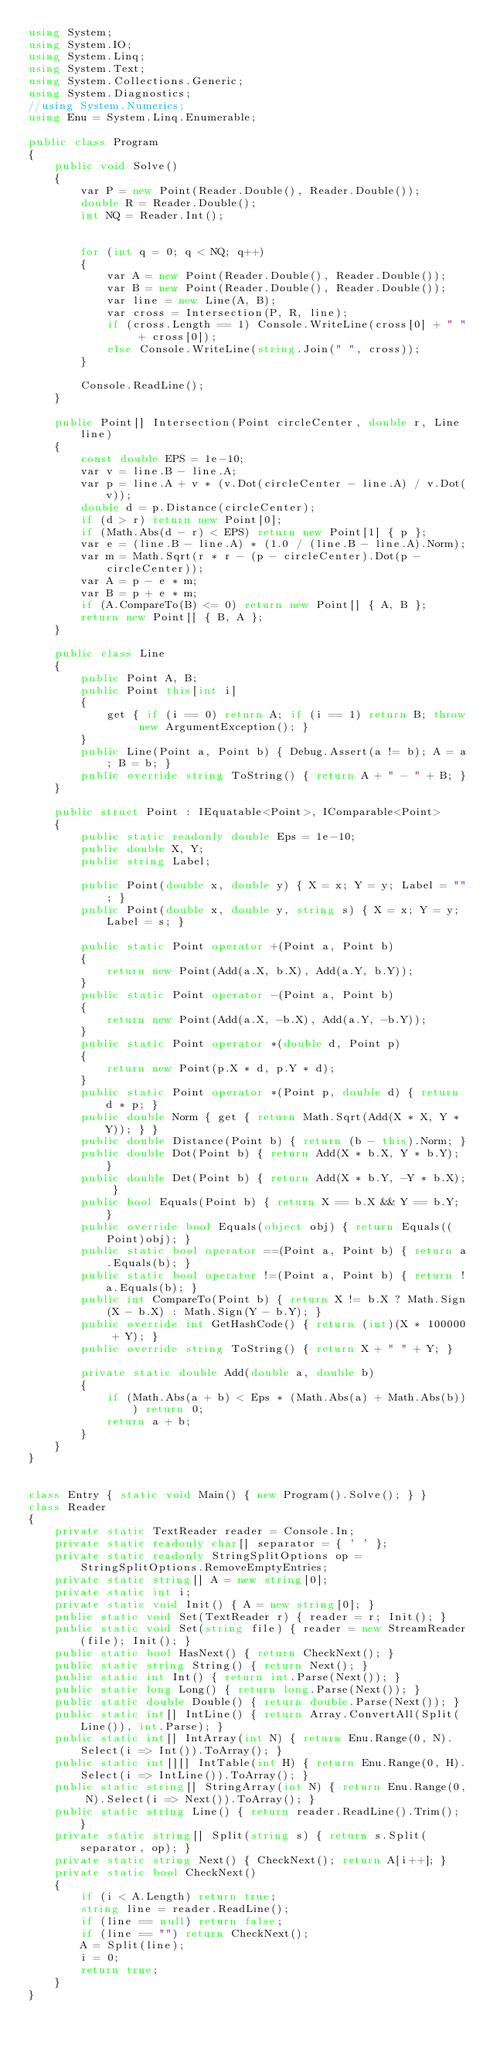Convert code to text. <code><loc_0><loc_0><loc_500><loc_500><_C#_>using System;
using System.IO;
using System.Linq;
using System.Text;
using System.Collections.Generic;
using System.Diagnostics;
//using System.Numerics;
using Enu = System.Linq.Enumerable;

public class Program
{
    public void Solve()
    {
        var P = new Point(Reader.Double(), Reader.Double());
        double R = Reader.Double();
        int NQ = Reader.Int();


        for (int q = 0; q < NQ; q++)
        {
            var A = new Point(Reader.Double(), Reader.Double());
            var B = new Point(Reader.Double(), Reader.Double());
            var line = new Line(A, B);
            var cross = Intersection(P, R, line);
            if (cross.Length == 1) Console.WriteLine(cross[0] + " " + cross[0]);
            else Console.WriteLine(string.Join(" ", cross));
        }

        Console.ReadLine();
    }

    public Point[] Intersection(Point circleCenter, double r, Line line)
    {
        const double EPS = 1e-10;
        var v = line.B - line.A;
        var p = line.A + v * (v.Dot(circleCenter - line.A) / v.Dot(v));
        double d = p.Distance(circleCenter);
        if (d > r) return new Point[0];
        if (Math.Abs(d - r) < EPS) return new Point[1] { p };
        var e = (line.B - line.A) * (1.0 / (line.B - line.A).Norm);
        var m = Math.Sqrt(r * r - (p - circleCenter).Dot(p - circleCenter));
        var A = p - e * m;
        var B = p + e * m;
        if (A.CompareTo(B) <= 0) return new Point[] { A, B };
        return new Point[] { B, A };
    }

    public class Line
    {
        public Point A, B;
        public Point this[int i]
        {
            get { if (i == 0) return A; if (i == 1) return B; throw new ArgumentException(); }
        }
        public Line(Point a, Point b) { Debug.Assert(a != b); A = a; B = b; }
        public override string ToString() { return A + " - " + B; }
    }

    public struct Point : IEquatable<Point>, IComparable<Point>
    {
        public static readonly double Eps = 1e-10;
        public double X, Y;
        public string Label;

        public Point(double x, double y) { X = x; Y = y; Label = ""; }
        public Point(double x, double y, string s) { X = x; Y = y; Label = s; }

        public static Point operator +(Point a, Point b)
        {
            return new Point(Add(a.X, b.X), Add(a.Y, b.Y));
        }
        public static Point operator -(Point a, Point b)
        {
            return new Point(Add(a.X, -b.X), Add(a.Y, -b.Y));
        }
        public static Point operator *(double d, Point p)
        {
            return new Point(p.X * d, p.Y * d);
        }
        public static Point operator *(Point p, double d) { return d * p; }
        public double Norm { get { return Math.Sqrt(Add(X * X, Y * Y)); } }
        public double Distance(Point b) { return (b - this).Norm; }
        public double Dot(Point b) { return Add(X * b.X, Y * b.Y); }
        public double Det(Point b) { return Add(X * b.Y, -Y * b.X); }
        public bool Equals(Point b) { return X == b.X && Y == b.Y; }
        public override bool Equals(object obj) { return Equals((Point)obj); }
        public static bool operator ==(Point a, Point b) { return a.Equals(b); }
        public static bool operator !=(Point a, Point b) { return !a.Equals(b); }
        public int CompareTo(Point b) { return X != b.X ? Math.Sign(X - b.X) : Math.Sign(Y - b.Y); }
        public override int GetHashCode() { return (int)(X * 100000 + Y); }
        public override string ToString() { return X + " " + Y; }

        private static double Add(double a, double b)
        {
            if (Math.Abs(a + b) < Eps * (Math.Abs(a) + Math.Abs(b))) return 0;
            return a + b;
        }
    }
}


class Entry { static void Main() { new Program().Solve(); } }
class Reader
{
    private static TextReader reader = Console.In;
    private static readonly char[] separator = { ' ' };
    private static readonly StringSplitOptions op = StringSplitOptions.RemoveEmptyEntries;
    private static string[] A = new string[0];
    private static int i;
    private static void Init() { A = new string[0]; }
    public static void Set(TextReader r) { reader = r; Init(); }
    public static void Set(string file) { reader = new StreamReader(file); Init(); }
    public static bool HasNext() { return CheckNext(); }
    public static string String() { return Next(); }
    public static int Int() { return int.Parse(Next()); }
    public static long Long() { return long.Parse(Next()); }
    public static double Double() { return double.Parse(Next()); }
    public static int[] IntLine() { return Array.ConvertAll(Split(Line()), int.Parse); }
    public static int[] IntArray(int N) { return Enu.Range(0, N).Select(i => Int()).ToArray(); }
    public static int[][] IntTable(int H) { return Enu.Range(0, H).Select(i => IntLine()).ToArray(); }
    public static string[] StringArray(int N) { return Enu.Range(0, N).Select(i => Next()).ToArray(); }
    public static string Line() { return reader.ReadLine().Trim(); }
    private static string[] Split(string s) { return s.Split(separator, op); }
    private static string Next() { CheckNext(); return A[i++]; }
    private static bool CheckNext()
    {
        if (i < A.Length) return true;
        string line = reader.ReadLine();
        if (line == null) return false;
        if (line == "") return CheckNext();
        A = Split(line);
        i = 0;
        return true;
    }
}</code> 